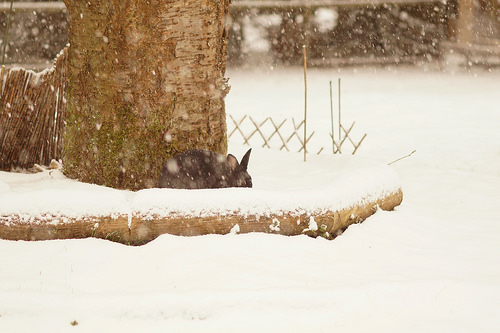<image>
Is there a tree on the ground? Yes. Looking at the image, I can see the tree is positioned on top of the ground, with the ground providing support. 